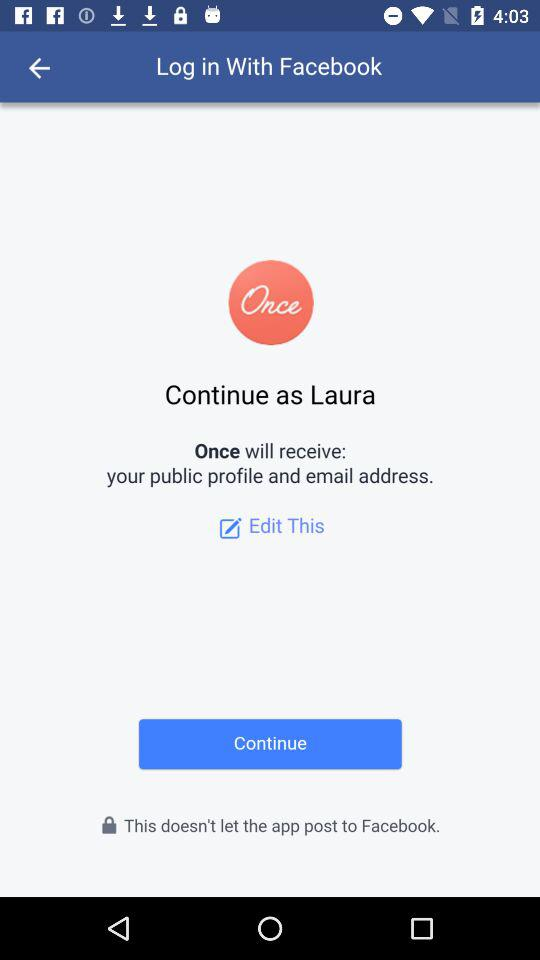What application will receive my public profile and email address? The application "Once" will receive your public profile and email address. 